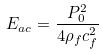<formula> <loc_0><loc_0><loc_500><loc_500>E _ { a c } = \frac { P _ { 0 } ^ { 2 } } { 4 \rho _ { f } c _ { f } ^ { 2 } }</formula> 